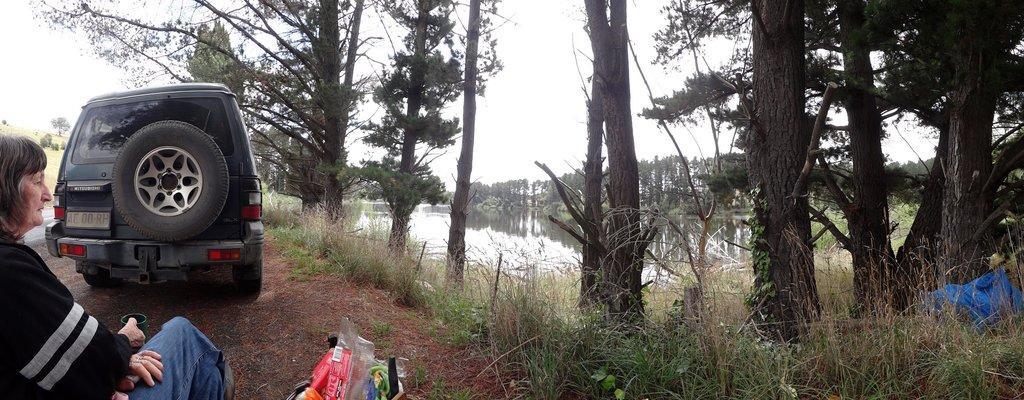Please provide a concise description of this image. In this image there the sky towards the top of the image, there are trees towards the top of the image, there is water, there are plants towards the bottom of the image, there are objects towards the bottom of the image, there is a woman sitting, she is holding an object, there is a vehicle, there is road towards the left of the image, there is grass towards the left of the image. 